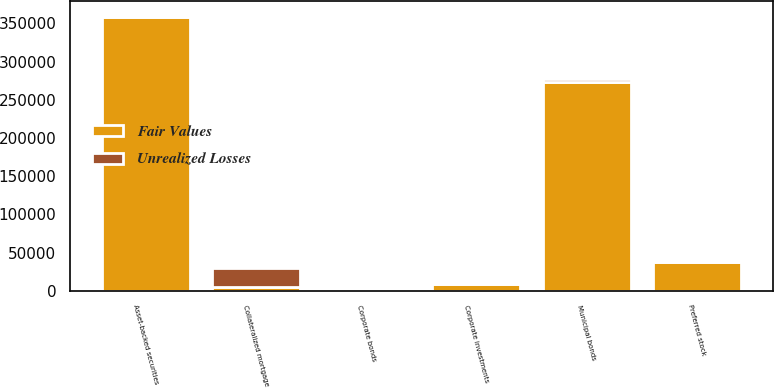Convert chart. <chart><loc_0><loc_0><loc_500><loc_500><stacked_bar_chart><ecel><fcel>Collateralized mortgage<fcel>Municipal bonds<fcel>Asset-backed securities<fcel>Corporate bonds<fcel>Preferred stock<fcel>Corporate investments<nl><fcel>Fair Values<fcel>4898<fcel>272698<fcel>358628<fcel>765<fcel>37663<fcel>8486<nl><fcel>Unrealized Losses<fcel>25415<fcel>4898<fcel>2520<fcel>23<fcel>420<fcel>1386<nl></chart> 